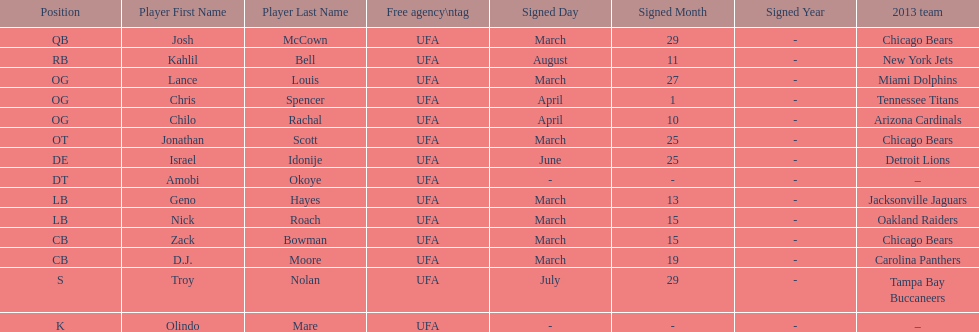Total number of players that signed in march? 7. 